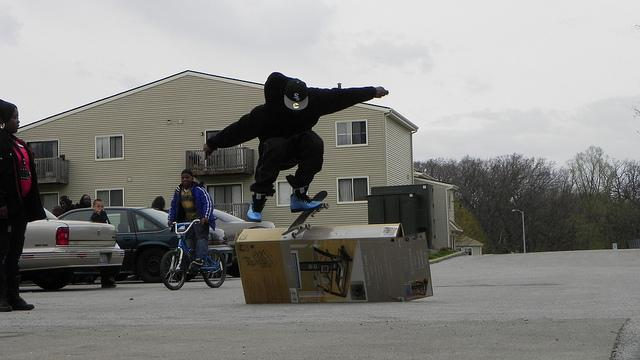What is the average size of skateboard? 31 inches 